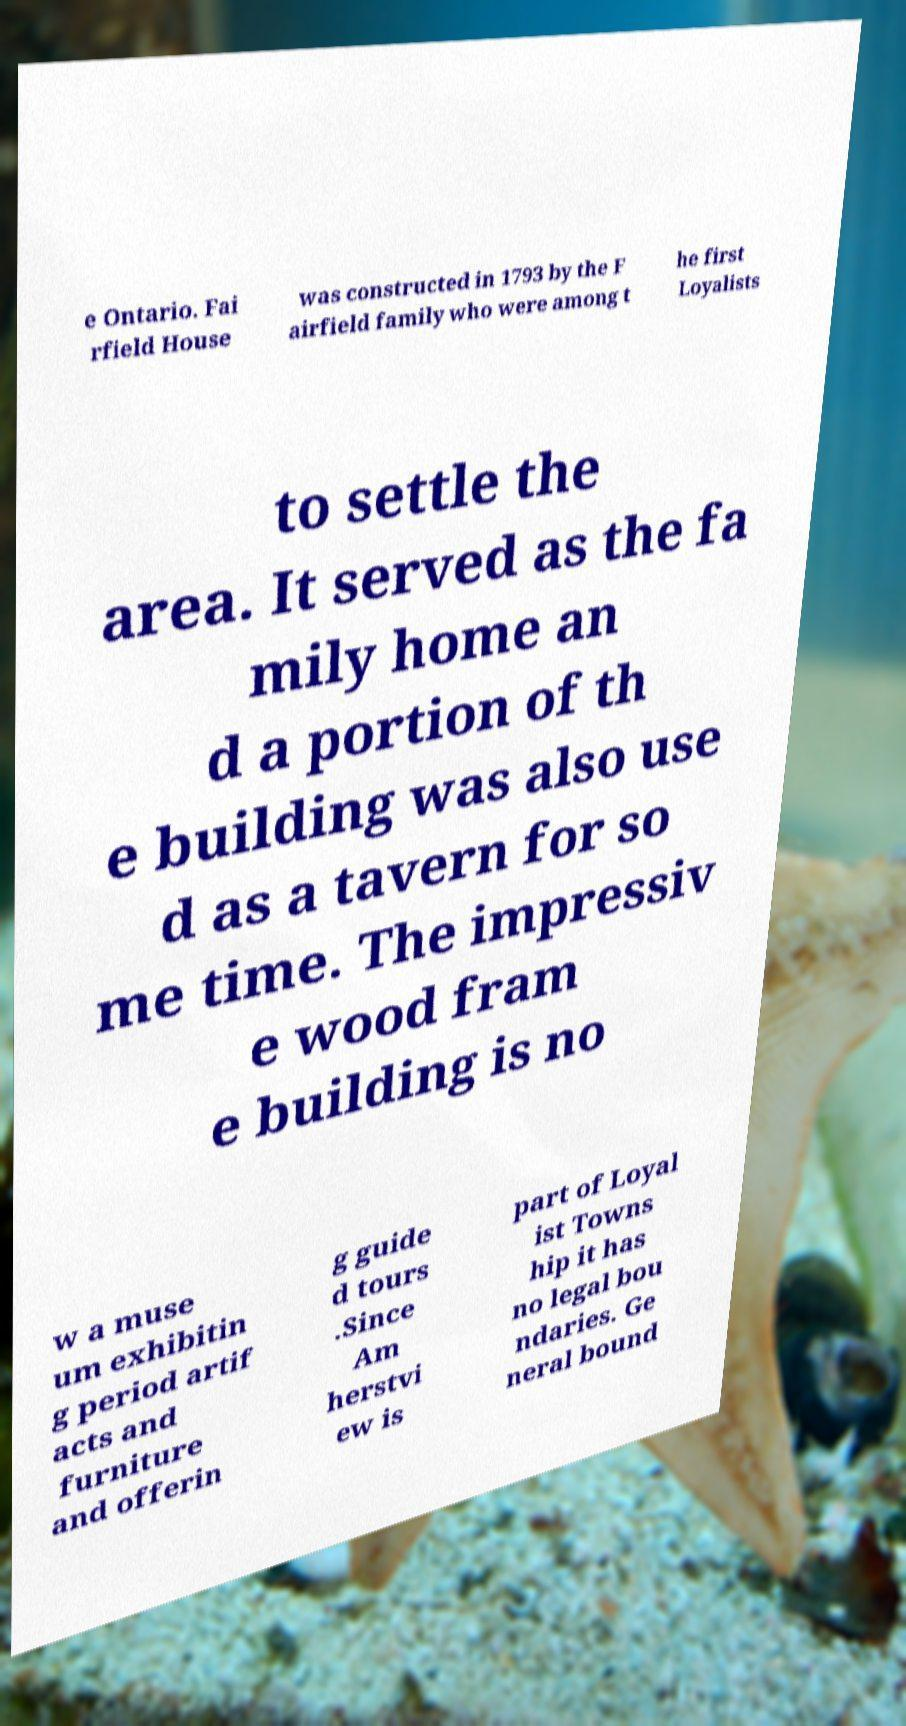For documentation purposes, I need the text within this image transcribed. Could you provide that? e Ontario. Fai rfield House was constructed in 1793 by the F airfield family who were among t he first Loyalists to settle the area. It served as the fa mily home an d a portion of th e building was also use d as a tavern for so me time. The impressiv e wood fram e building is no w a muse um exhibitin g period artif acts and furniture and offerin g guide d tours .Since Am herstvi ew is part of Loyal ist Towns hip it has no legal bou ndaries. Ge neral bound 